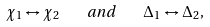<formula> <loc_0><loc_0><loc_500><loc_500>\chi _ { 1 } \leftrightarrow \chi _ { 2 } \quad a n d \quad \Delta _ { 1 } \leftrightarrow \Delta _ { 2 } ,</formula> 